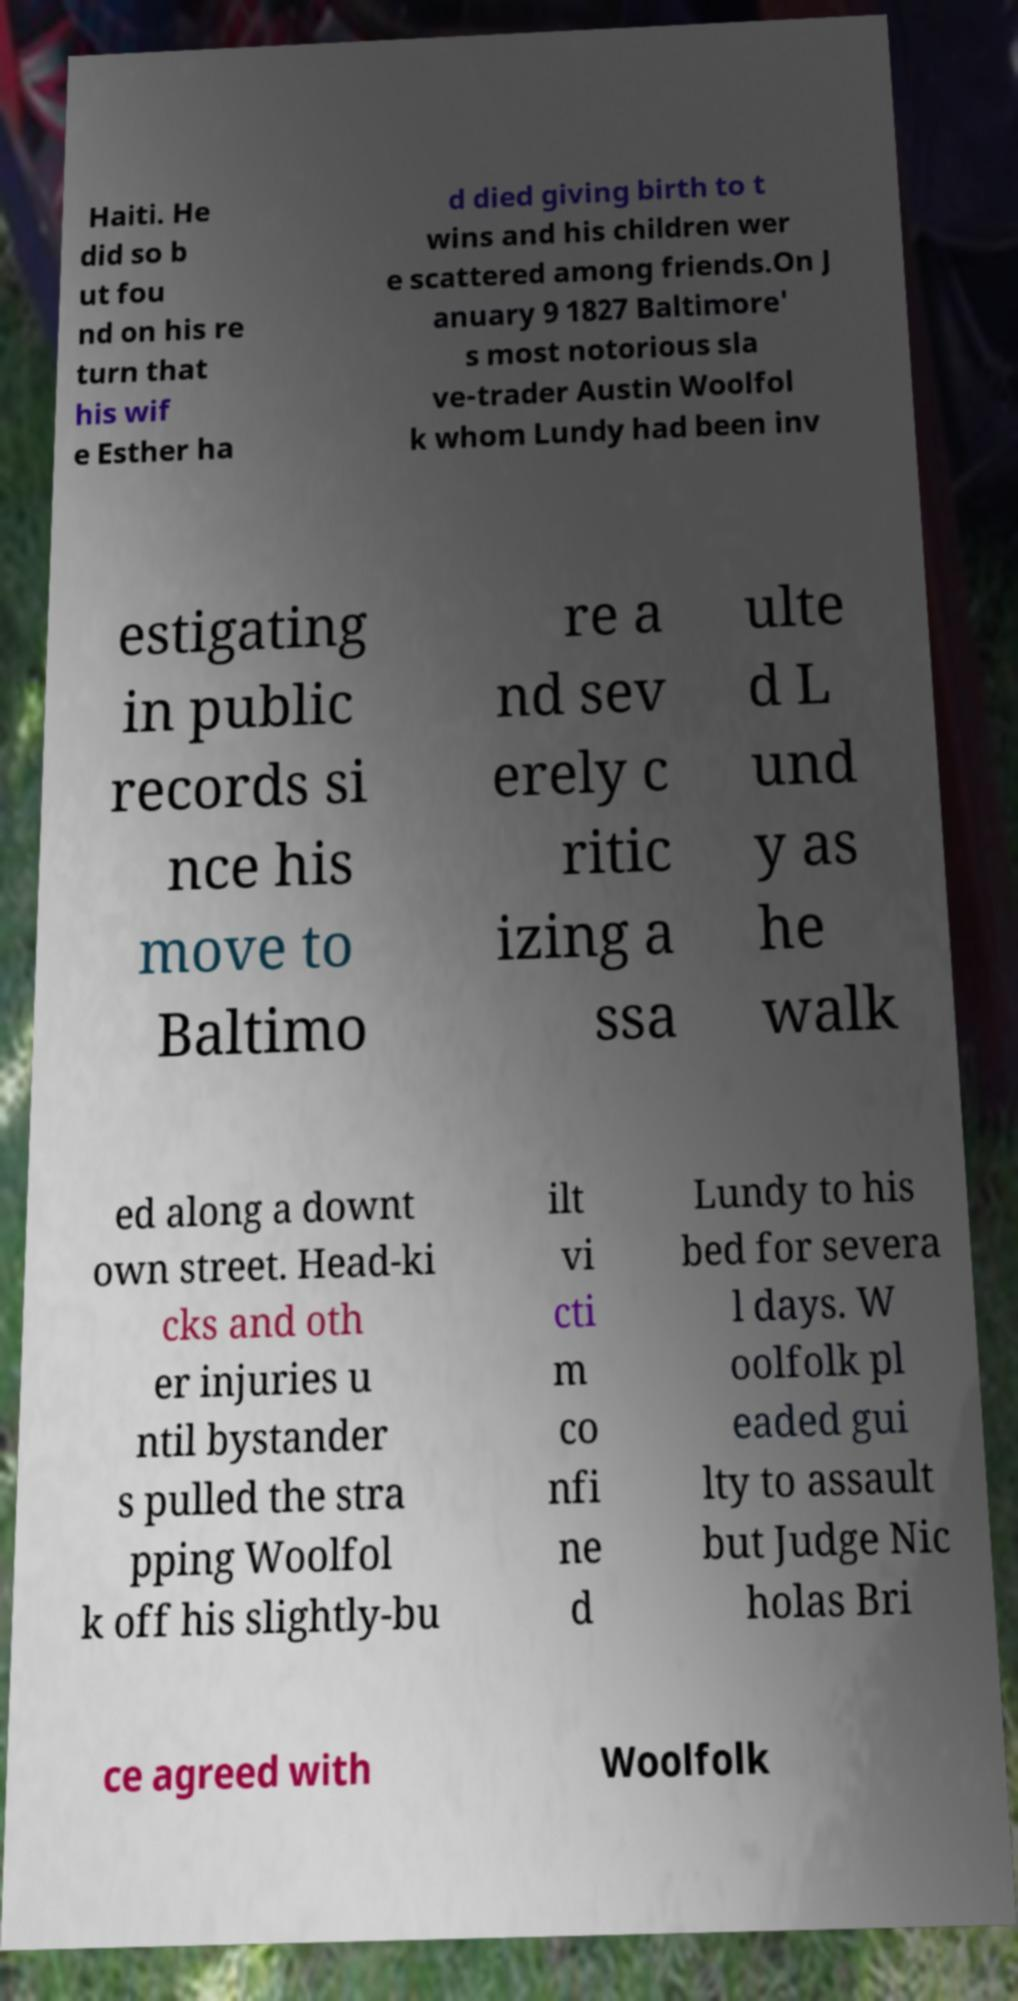Please identify and transcribe the text found in this image. Haiti. He did so b ut fou nd on his re turn that his wif e Esther ha d died giving birth to t wins and his children wer e scattered among friends.On J anuary 9 1827 Baltimore' s most notorious sla ve-trader Austin Woolfol k whom Lundy had been inv estigating in public records si nce his move to Baltimo re a nd sev erely c ritic izing a ssa ulte d L und y as he walk ed along a downt own street. Head-ki cks and oth er injuries u ntil bystander s pulled the stra pping Woolfol k off his slightly-bu ilt vi cti m co nfi ne d Lundy to his bed for severa l days. W oolfolk pl eaded gui lty to assault but Judge Nic holas Bri ce agreed with Woolfolk 